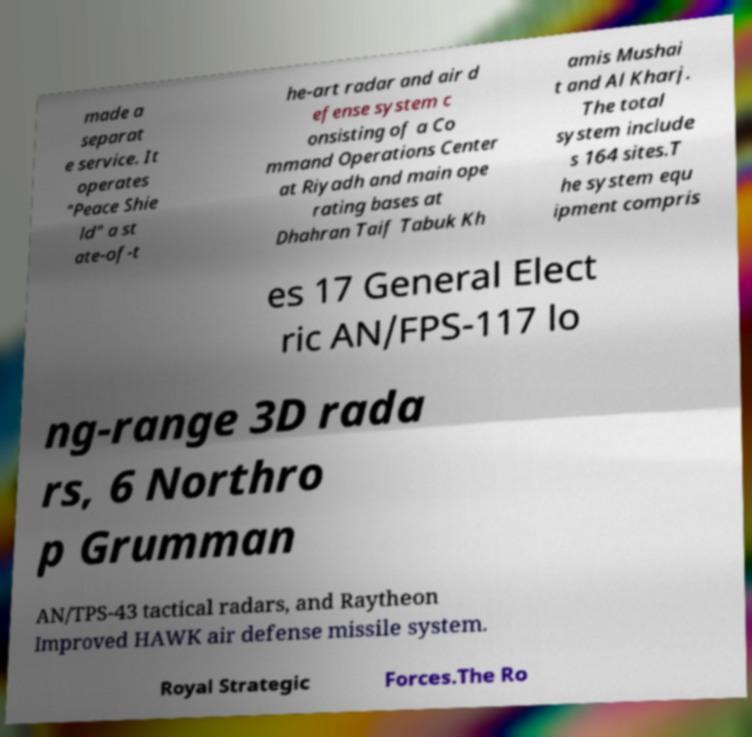Could you extract and type out the text from this image? made a separat e service. It operates "Peace Shie ld" a st ate-of-t he-art radar and air d efense system c onsisting of a Co mmand Operations Center at Riyadh and main ope rating bases at Dhahran Taif Tabuk Kh amis Mushai t and Al Kharj. The total system include s 164 sites.T he system equ ipment compris es 17 General Elect ric AN/FPS-117 lo ng-range 3D rada rs, 6 Northro p Grumman AN/TPS-43 tactical radars, and Raytheon Improved HAWK air defense missile system. Royal Strategic Forces.The Ro 